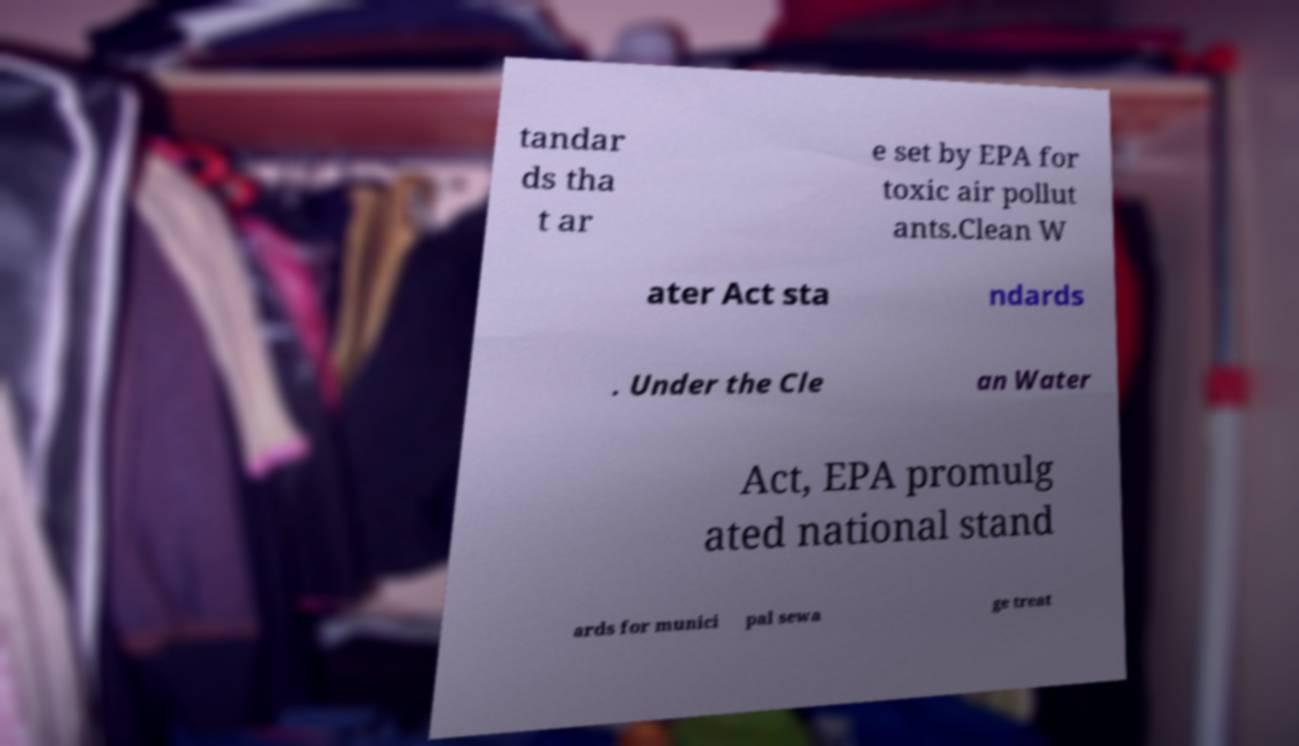What messages or text are displayed in this image? I need them in a readable, typed format. tandar ds tha t ar e set by EPA for toxic air pollut ants.Clean W ater Act sta ndards . Under the Cle an Water Act, EPA promulg ated national stand ards for munici pal sewa ge treat 